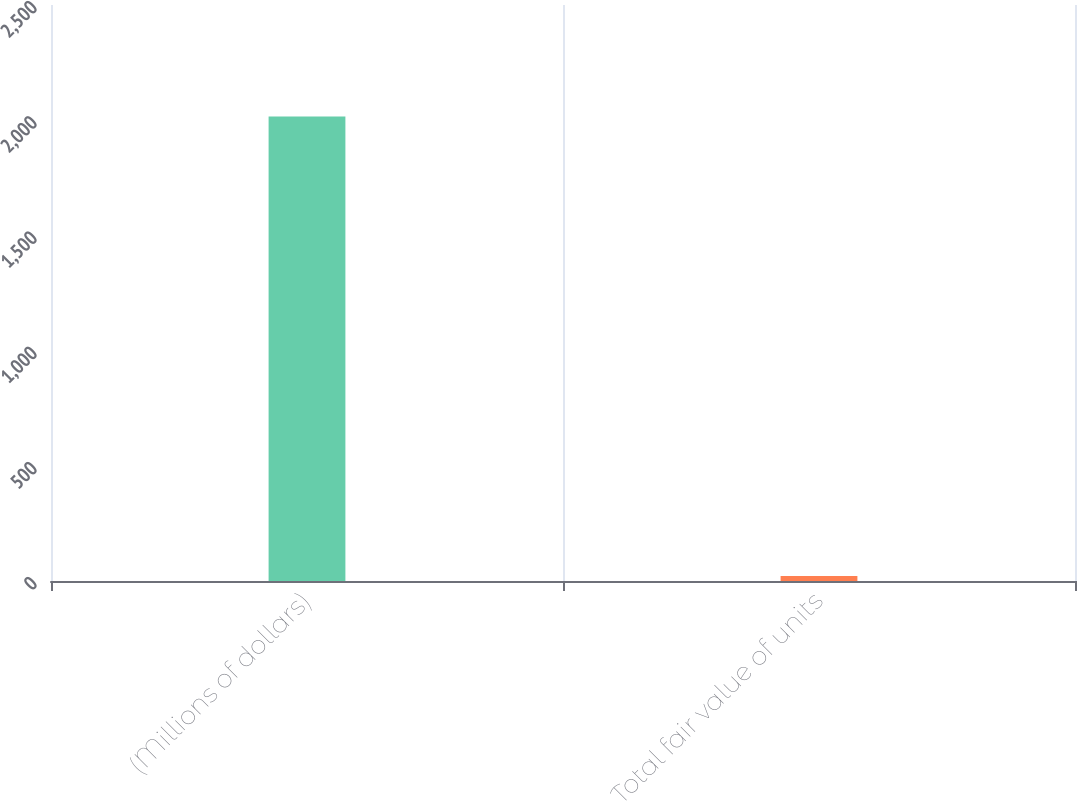Convert chart. <chart><loc_0><loc_0><loc_500><loc_500><bar_chart><fcel>(Millions of dollars)<fcel>Total fair value of units<nl><fcel>2016<fcel>22<nl></chart> 